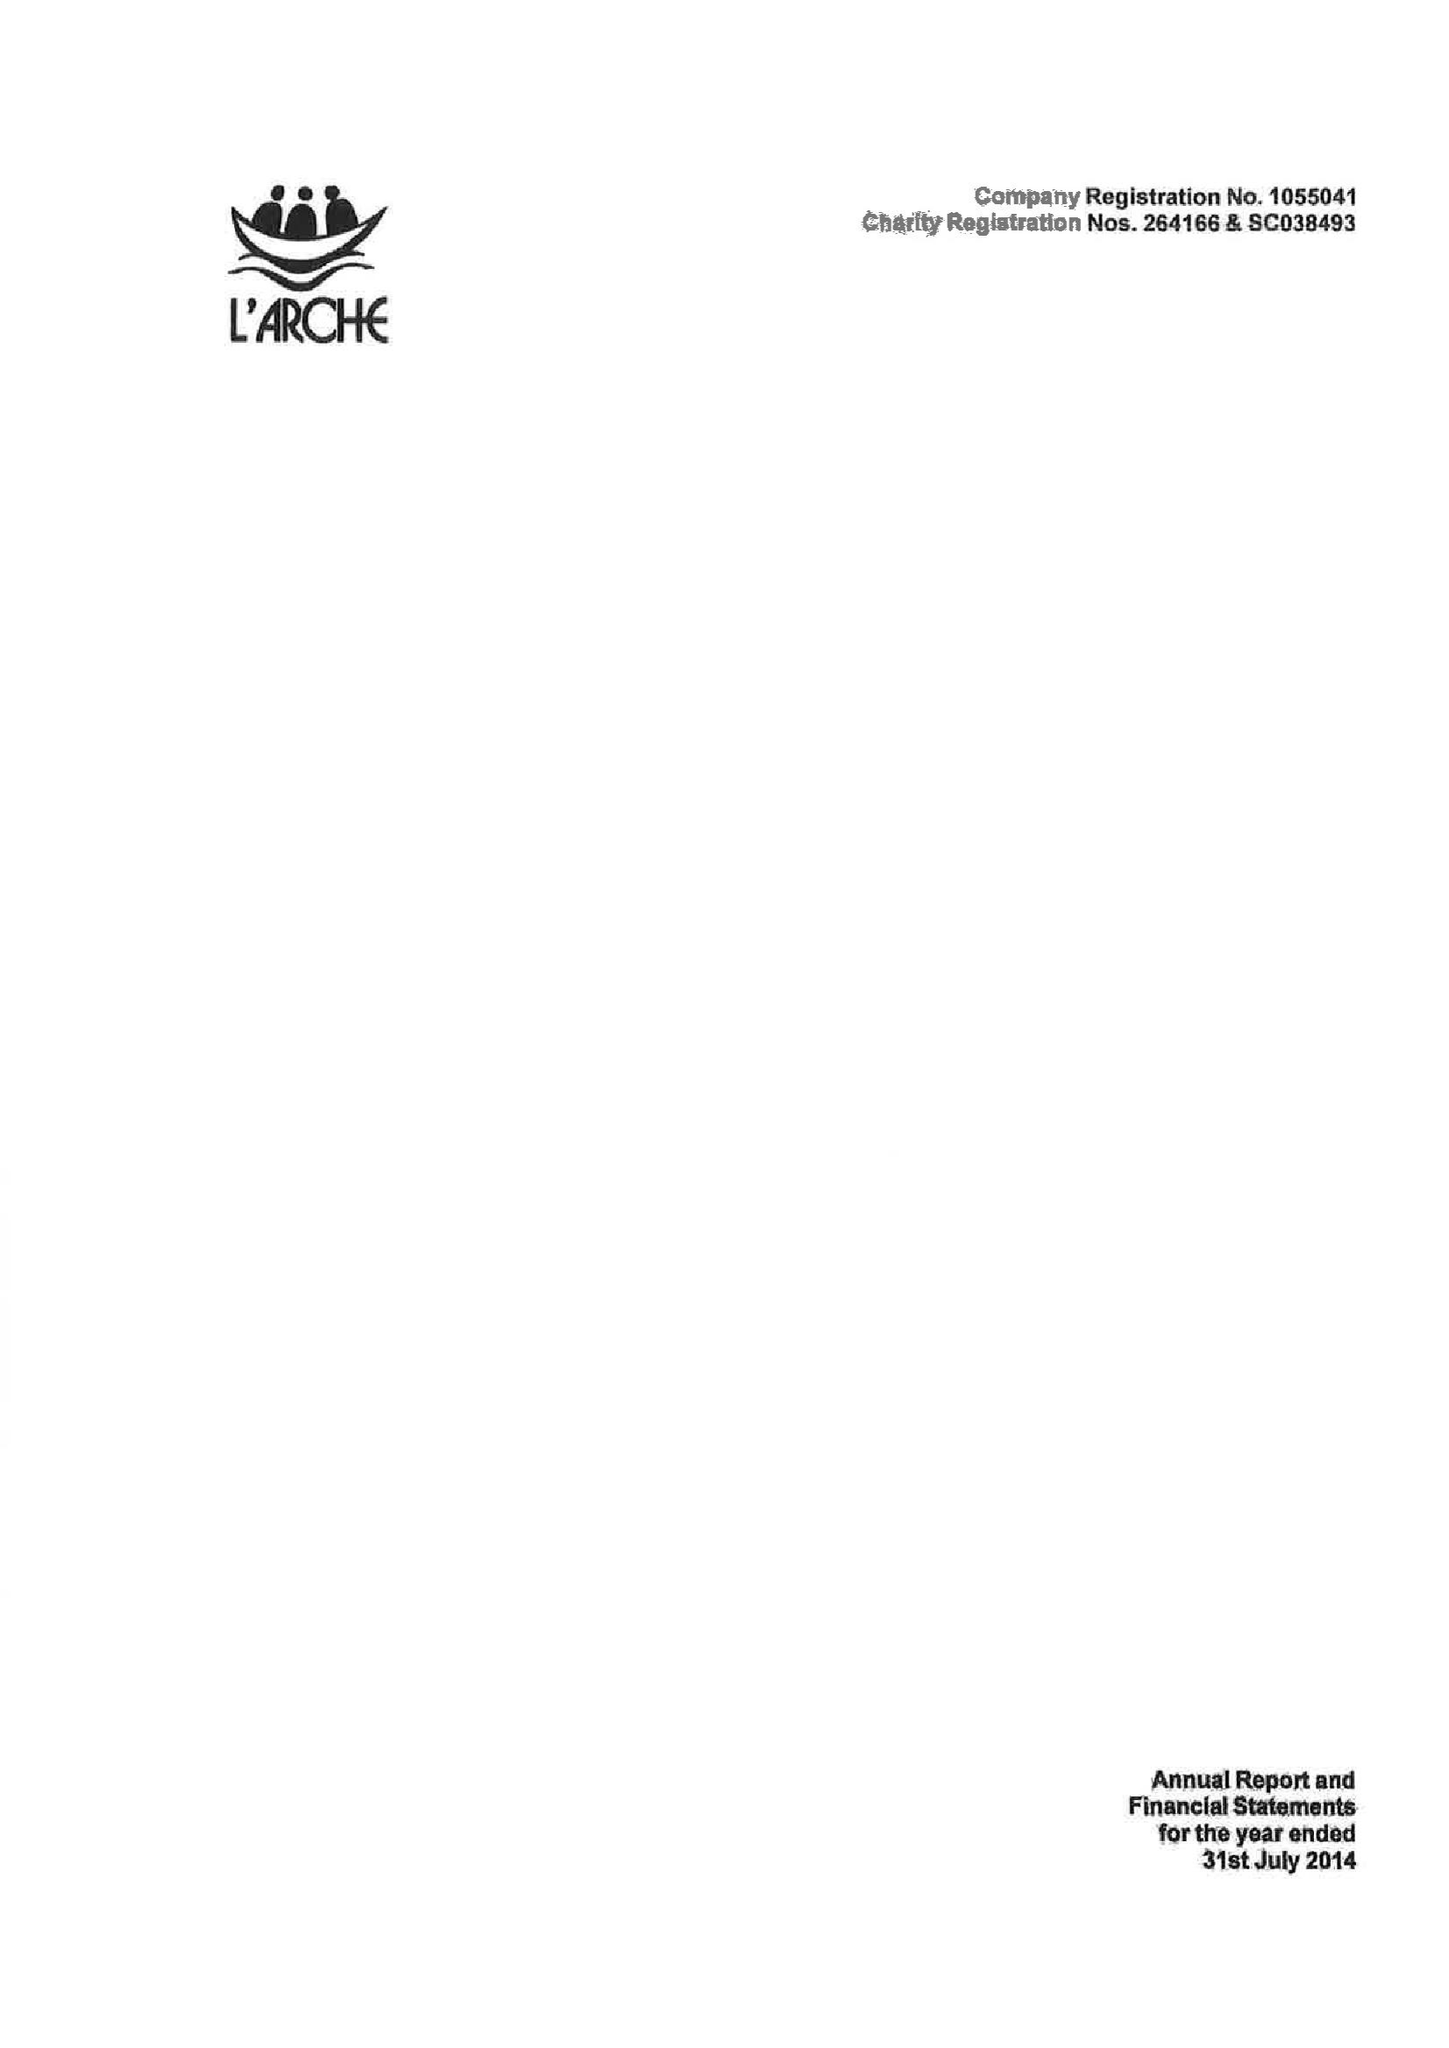What is the value for the spending_annually_in_british_pounds?
Answer the question using a single word or phrase. 8013855.00 